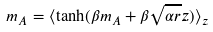<formula> <loc_0><loc_0><loc_500><loc_500>m _ { A } = \langle \tanh ( \beta m _ { A } + \beta \sqrt { \alpha r } z ) \rangle _ { z }</formula> 